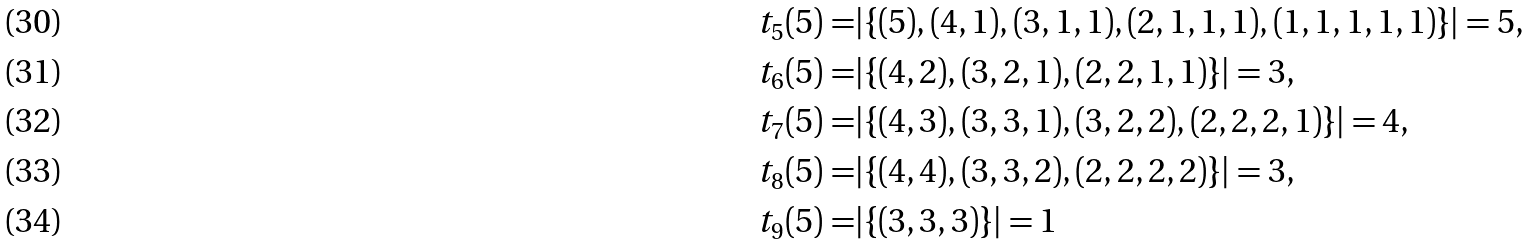<formula> <loc_0><loc_0><loc_500><loc_500>t _ { 5 } ( 5 ) = & | \{ ( 5 ) , ( 4 , 1 ) , ( 3 , 1 , 1 ) , ( 2 , 1 , 1 , 1 ) , ( 1 , 1 , 1 , 1 , 1 ) \} | = 5 , \\ t _ { 6 } ( 5 ) = & | \{ ( 4 , 2 ) , ( 3 , 2 , 1 ) , ( 2 , 2 , 1 , 1 ) \} | = 3 , \\ t _ { 7 } ( 5 ) = & | \{ ( 4 , 3 ) , ( 3 , 3 , 1 ) , ( 3 , 2 , 2 ) , ( 2 , 2 , 2 , 1 ) \} | = 4 , \\ t _ { 8 } ( 5 ) = & | \{ ( 4 , 4 ) , ( 3 , 3 , 2 ) , ( 2 , 2 , 2 , 2 ) \} | = 3 , \\ t _ { 9 } ( 5 ) = & | \{ ( 3 , 3 , 3 ) \} | = 1</formula> 